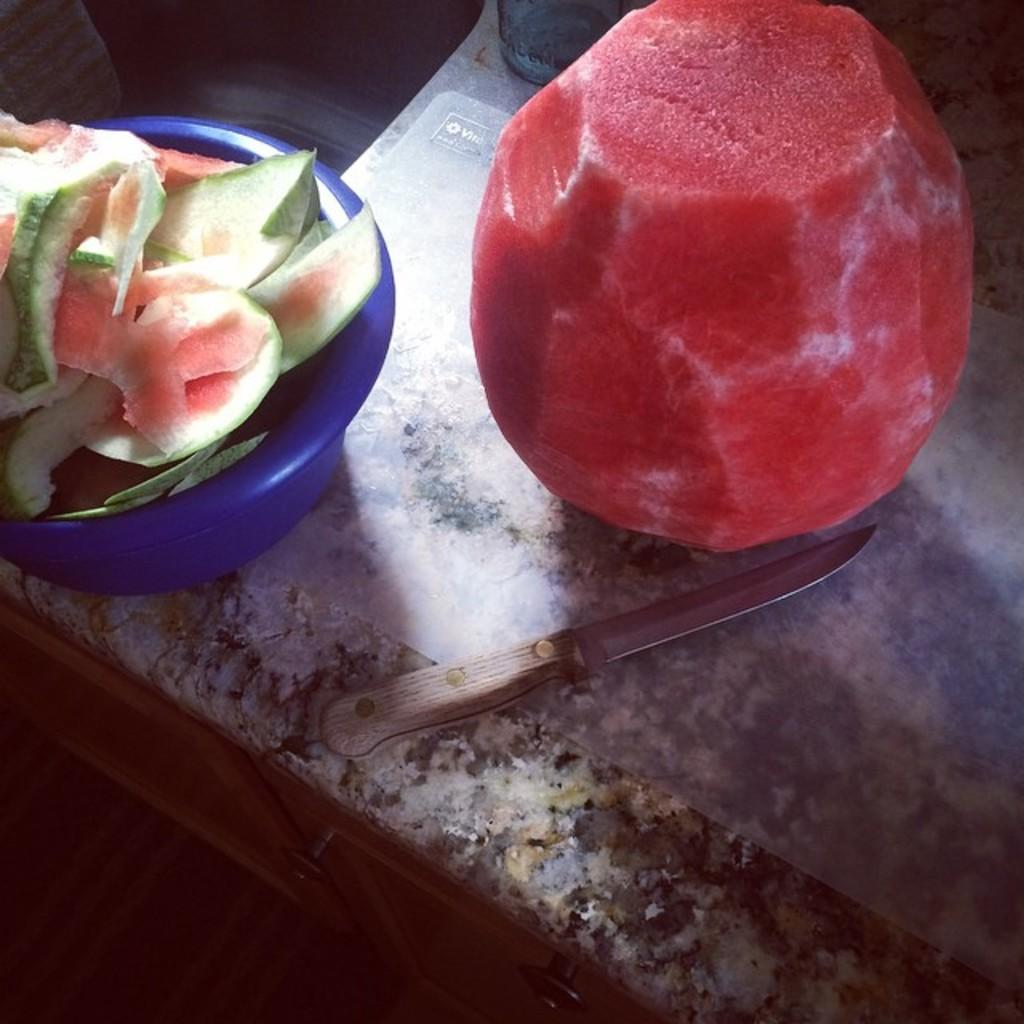What type of surface is visible in the image? There is a counter table in the image. What object can be seen on the counter table? There is a knife on the counter table. What else is on the counter table besides the knife? There is a bowl, watermelon peels, an unspecified object, and a watermelon on the counter table. What type of office supplies are present on the counter table in the image? There is no mention of office supplies in the image; it features a counter table with various objects related to a watermelon. 